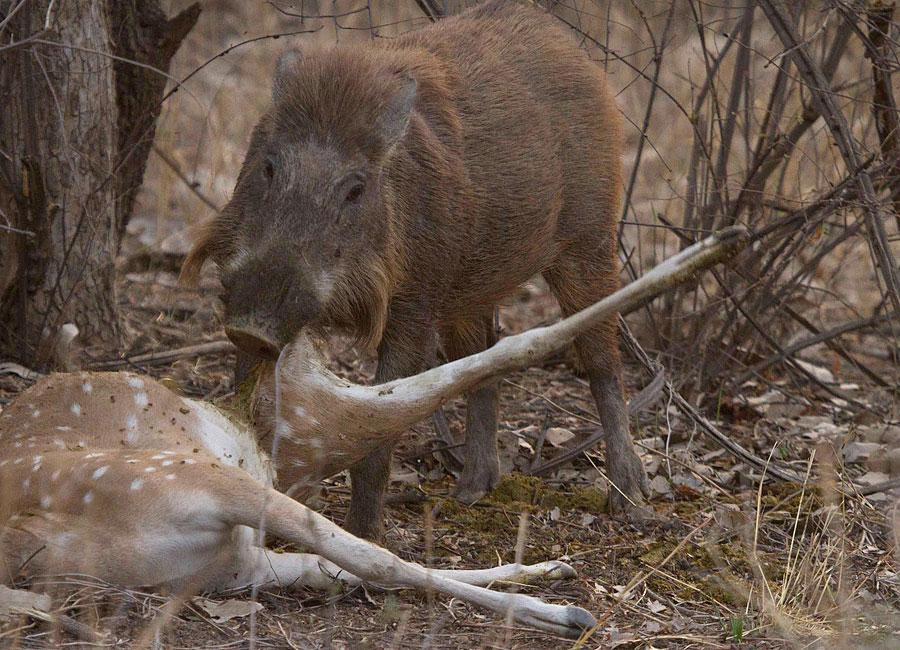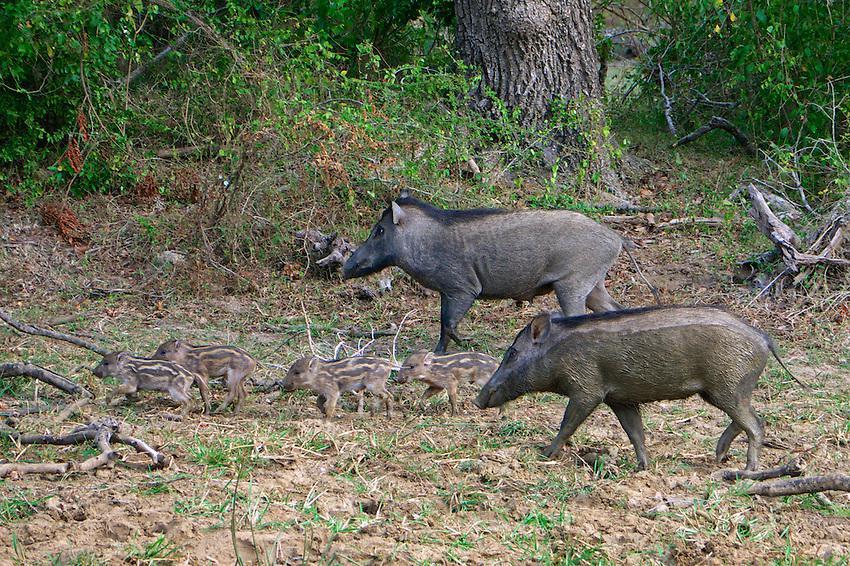The first image is the image on the left, the second image is the image on the right. Evaluate the accuracy of this statement regarding the images: "An image shows one wild pig with the carcass of a spotted hooved animal.". Is it true? Answer yes or no. Yes. The first image is the image on the left, the second image is the image on the right. Given the left and right images, does the statement "There are two wild pigs out in the wild." hold true? Answer yes or no. No. 